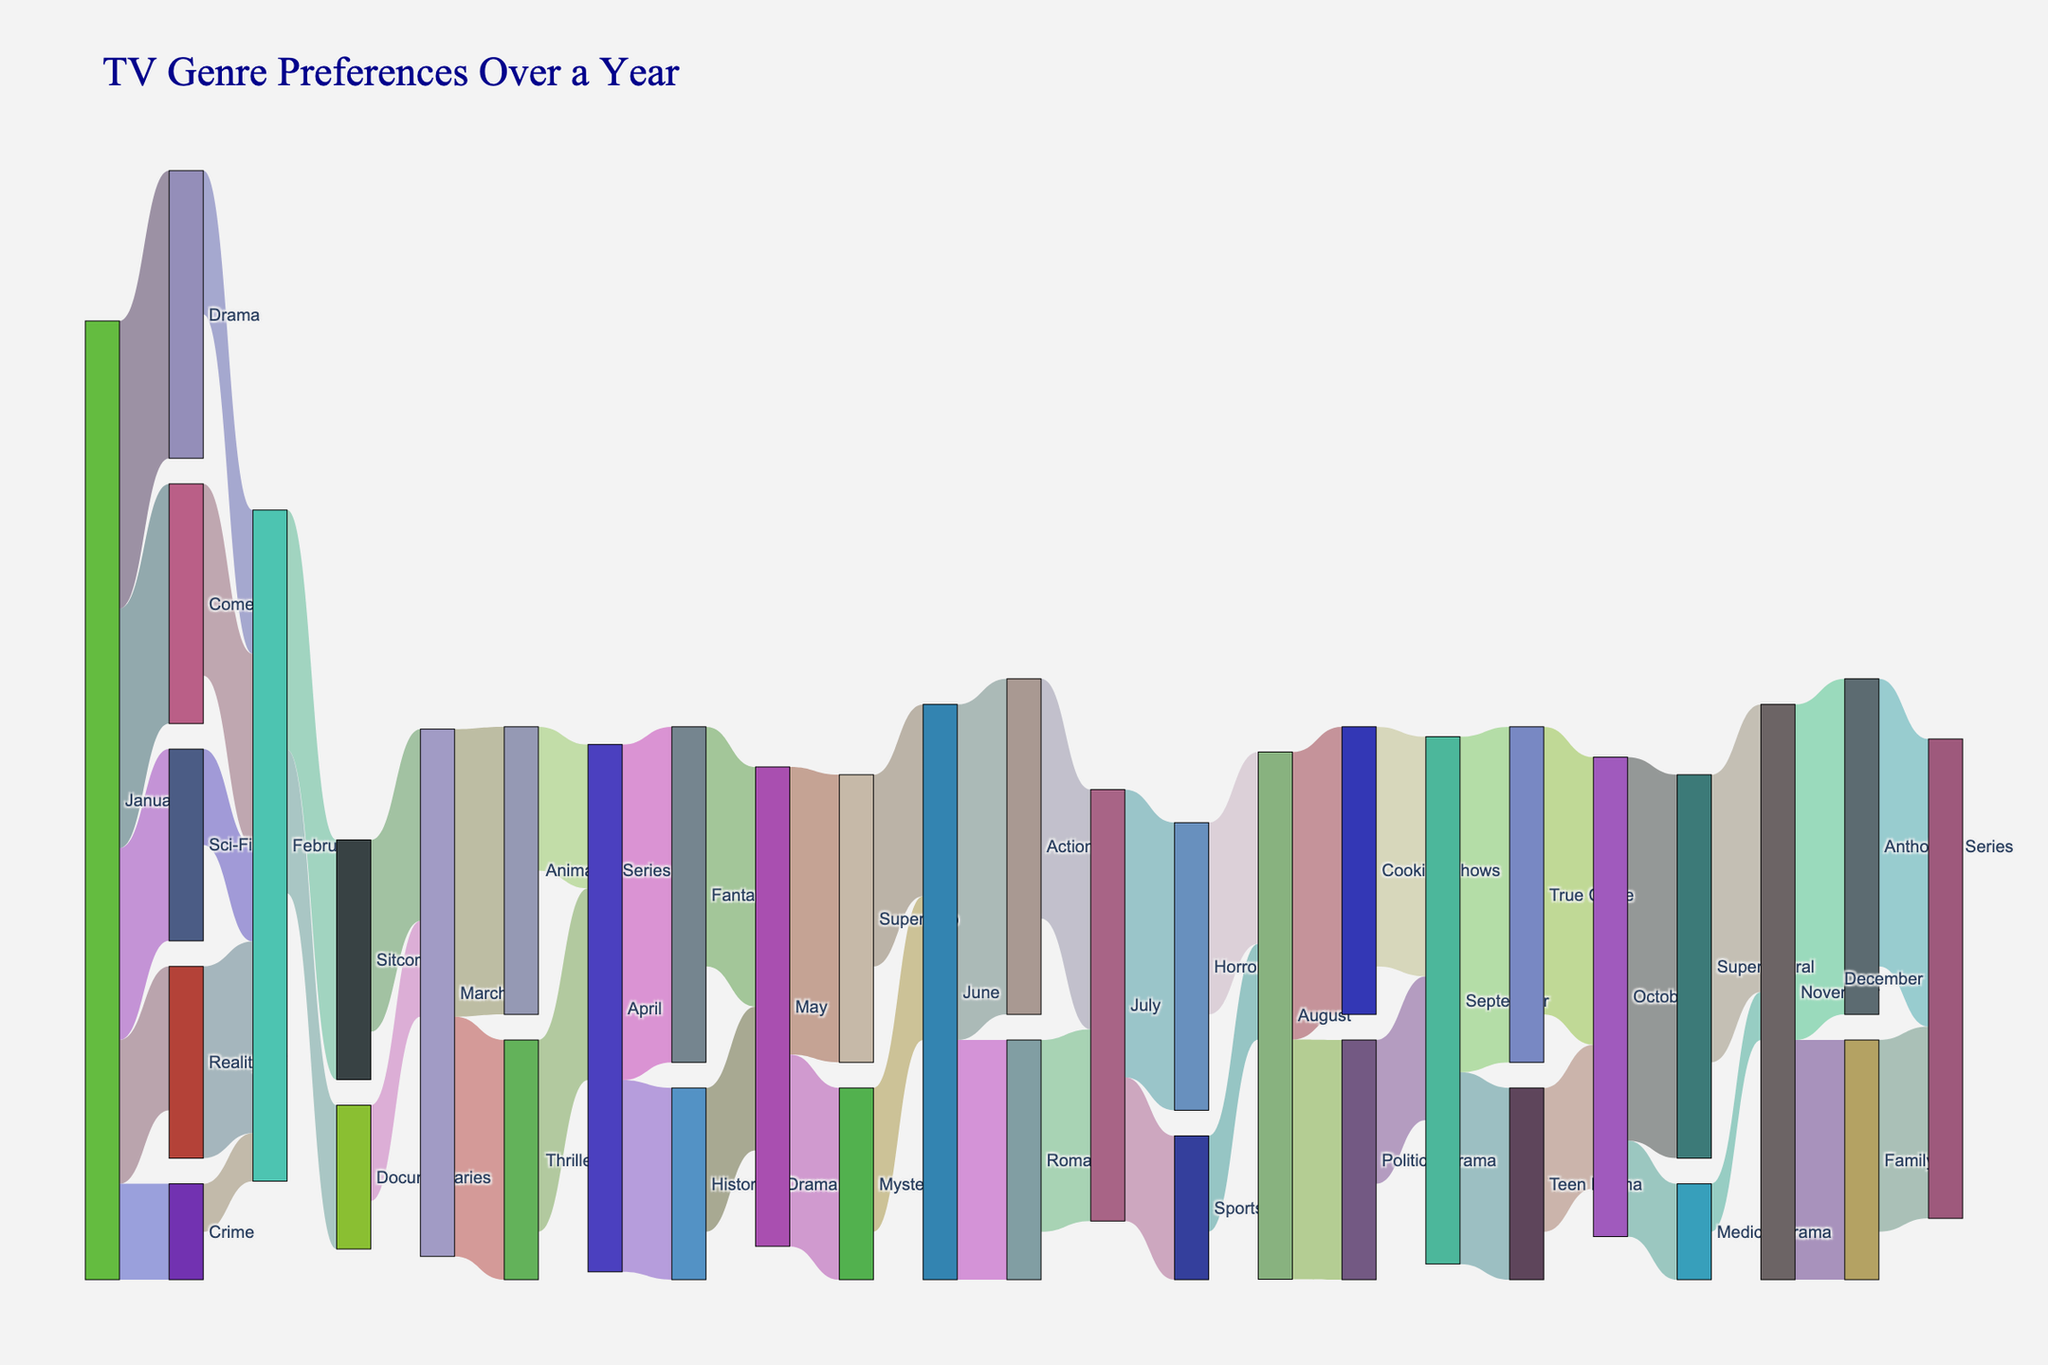What's the title of the Sankey diagram? The title is displayed at the top of the diagram. By looking at the figure, you can see the text that describes what the diagram represents.
Answer: TV Genre Preferences Over a Year How many genres does January split into? To find out the number of genres from January, count the number of lines leading out from January.
Answer: 5 Which genre had the highest flow from February to March? Observe the connections leading from February to March and compare their widths. The one with the widest width represents the highest flow.
Answer: Sitcom In which month does the viewership first shift towards Crime genres? Trace the flow that leads to the Crime genre. The first occurrence month in the flow is the answer.
Answer: January What's the cumulative value of viewers transitioning to March? Add the values of all links entering March by referring to their flow values.
Answer: 30 + 25 = 55 Which month has the maximum variety of genres that viewers split into? Look for the month with the most outgoing connections by counting the lines leading out of each month.
Answer: September Compare the viewer flow from Drama in January to any month in the first quarter. Find the links leading from Drama in January to any other month within the first three months and compare their values.
Answer: February: 15 What genre received 30 viewers in October, and what is its flow in November? Identify the connection in October that indicates 30 viewers, then trace that flow to November.
Answer: Supernatural; 30 Which genre received the least viewers from January? Compare the values of all links leading out of January. The smallest value represents the least viewed genre.
Answer: Crime 